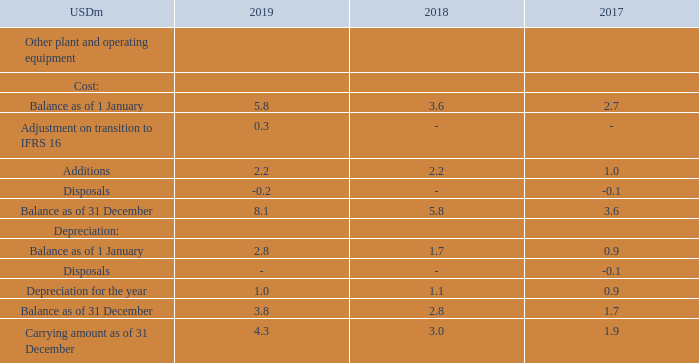NOTE 6 - continued
For information on assets provided as collateral security, please refer to note 16. Please refer to note 8 for information on impairment testing.
The depreciation expense related to "Other plant and operating equipment" of USD 1.0m relates to "Administrative expense" (2018: USD 1.1m, 2017: USD 0.9m). Depreciation and impairment losses on tangible fixed assets on "Vessels and capitalized dry-docking" relate to operating expenses.
What information can be derived in note 16? Information on assets provided as collateral security. What was the depreciation expense related to Other plant and operating equipment? Usd 1.0m. What are the broad categories analyzed under Other plant and operating equipment? Cost, depreciation. In which year was the amount of depreciation for the year the largest? 1.1>1.0>0.9
Answer: 2018. What was the change in the carrying amount as of 31 December from 2018 to 2019?
Answer scale should be: million. 4.3-3.0
Answer: 1.3. What was the percentage change in the carrying amount as of 31 December from 2018 to 2019?
Answer scale should be: percent. (4.3-3.0)/3.0
Answer: 43.33. 